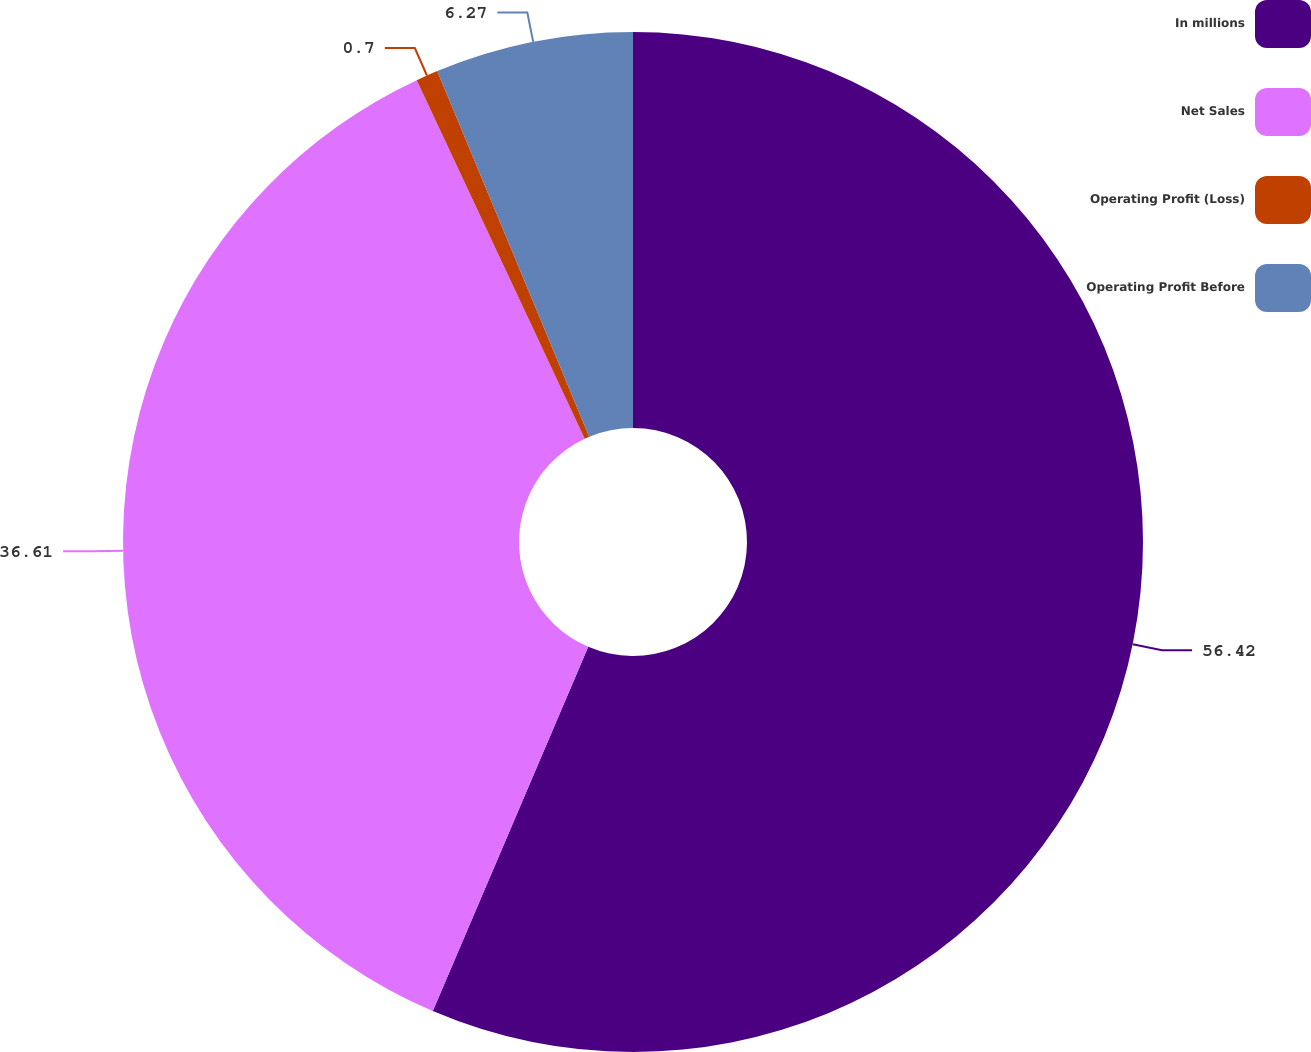Convert chart. <chart><loc_0><loc_0><loc_500><loc_500><pie_chart><fcel>In millions<fcel>Net Sales<fcel>Operating Profit (Loss)<fcel>Operating Profit Before<nl><fcel>56.42%<fcel>36.61%<fcel>0.7%<fcel>6.27%<nl></chart> 